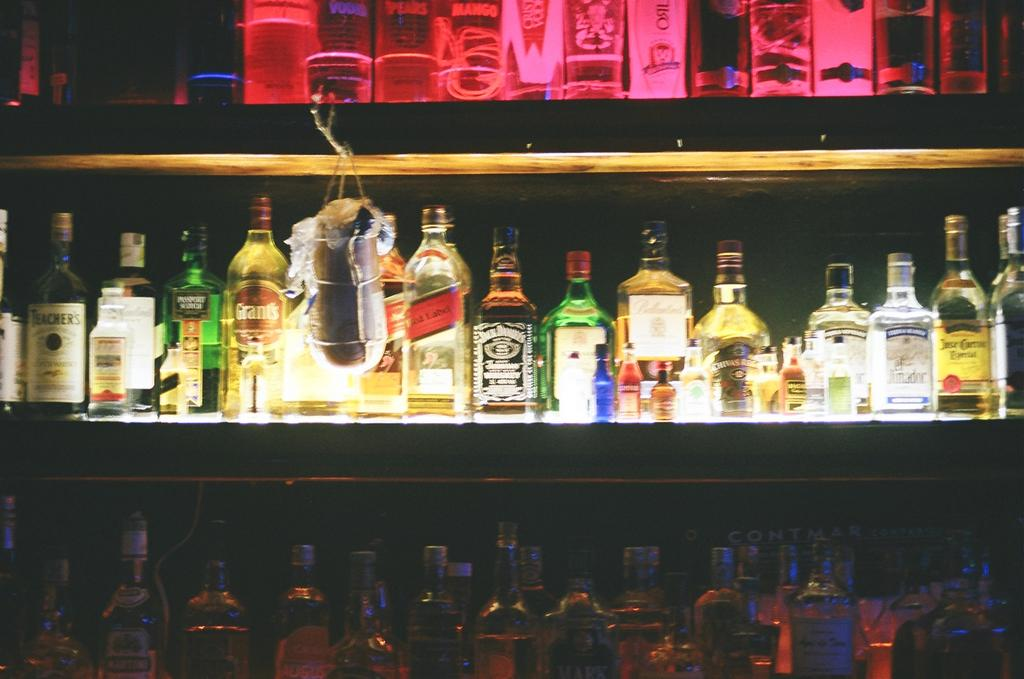What is the main subject of the image? The main subject of the image is a rack of wine. What is stored on the rack? The rack contains bottles of wine. Are the bottles of wine full or empty? The bottles of wine are full. Are there any other types of alcoholic beverages in the image? Yes, there are bottles of alcohol in the image. What is the acoustics like in the image? The image does not provide any information about the acoustics, as it focuses on a rack of wine and bottles of alcohol. 